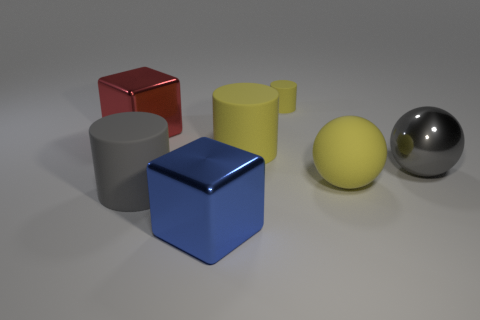What number of other objects are the same material as the tiny yellow thing?
Make the answer very short. 3. There is a red metal cube; does it have the same size as the cylinder behind the large red shiny cube?
Your answer should be very brief. No. Does the yellow rubber cylinder in front of the small matte object have the same size as the yellow cylinder behind the large red block?
Keep it short and to the point. No. What size is the gray object that is the same shape as the tiny yellow thing?
Your response must be concise. Large. What number of objects are big gray metal spheres or yellow cylinders?
Give a very brief answer. 3. There is a big gray object to the right of the tiny cylinder; are there any spheres that are in front of it?
Provide a short and direct response. Yes. Is the number of big cylinders to the right of the big blue thing greater than the number of tiny cylinders that are right of the yellow matte ball?
Your answer should be compact. Yes. What number of metal spheres are the same color as the large rubber sphere?
Your answer should be very brief. 0. There is a big cylinder that is in front of the big gray shiny ball; is it the same color as the metallic object on the right side of the large yellow matte ball?
Offer a terse response. Yes. Are there any small rubber things on the left side of the tiny yellow object?
Your answer should be compact. No. 